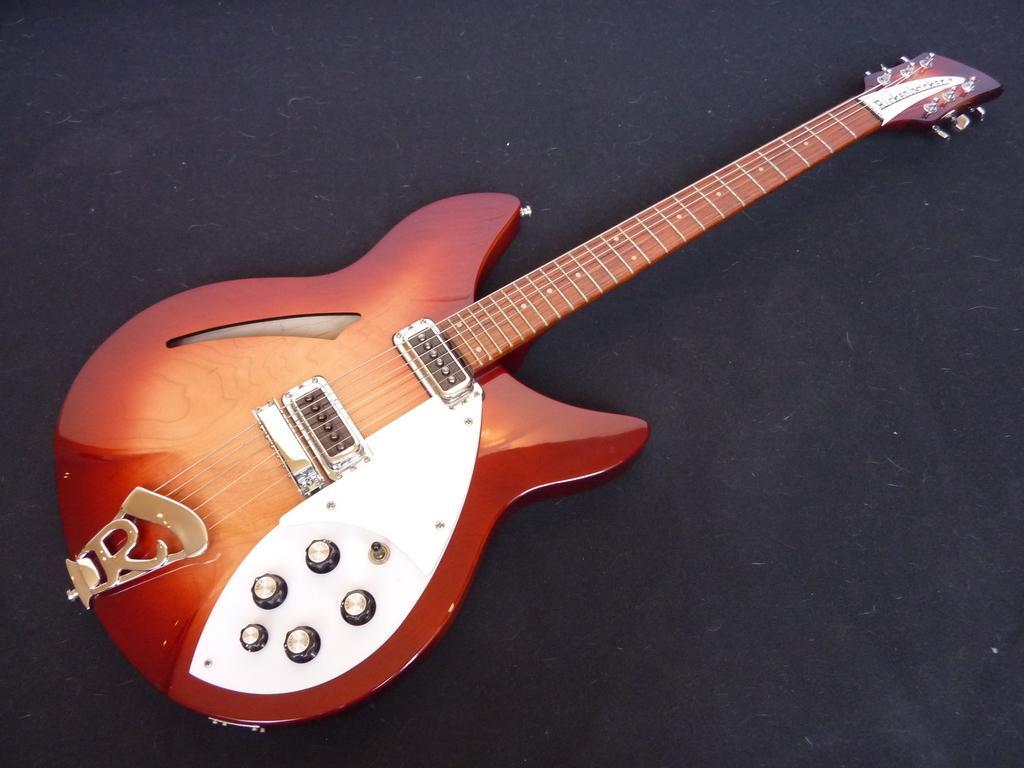Describe this image in one or two sentences. In this image there is a guitar with multiple colors and it has six strings and few knobs on it. 